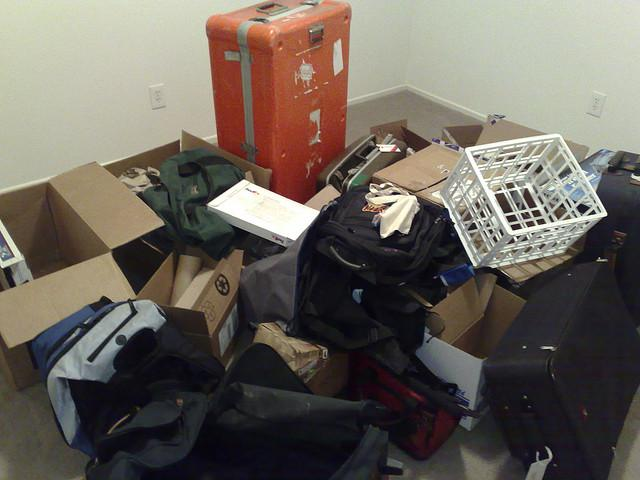What is someone who collects huge amounts of rubbish called? Please explain your reasoning. hoarder. This group of people can't bring themselves to throw anything out. 